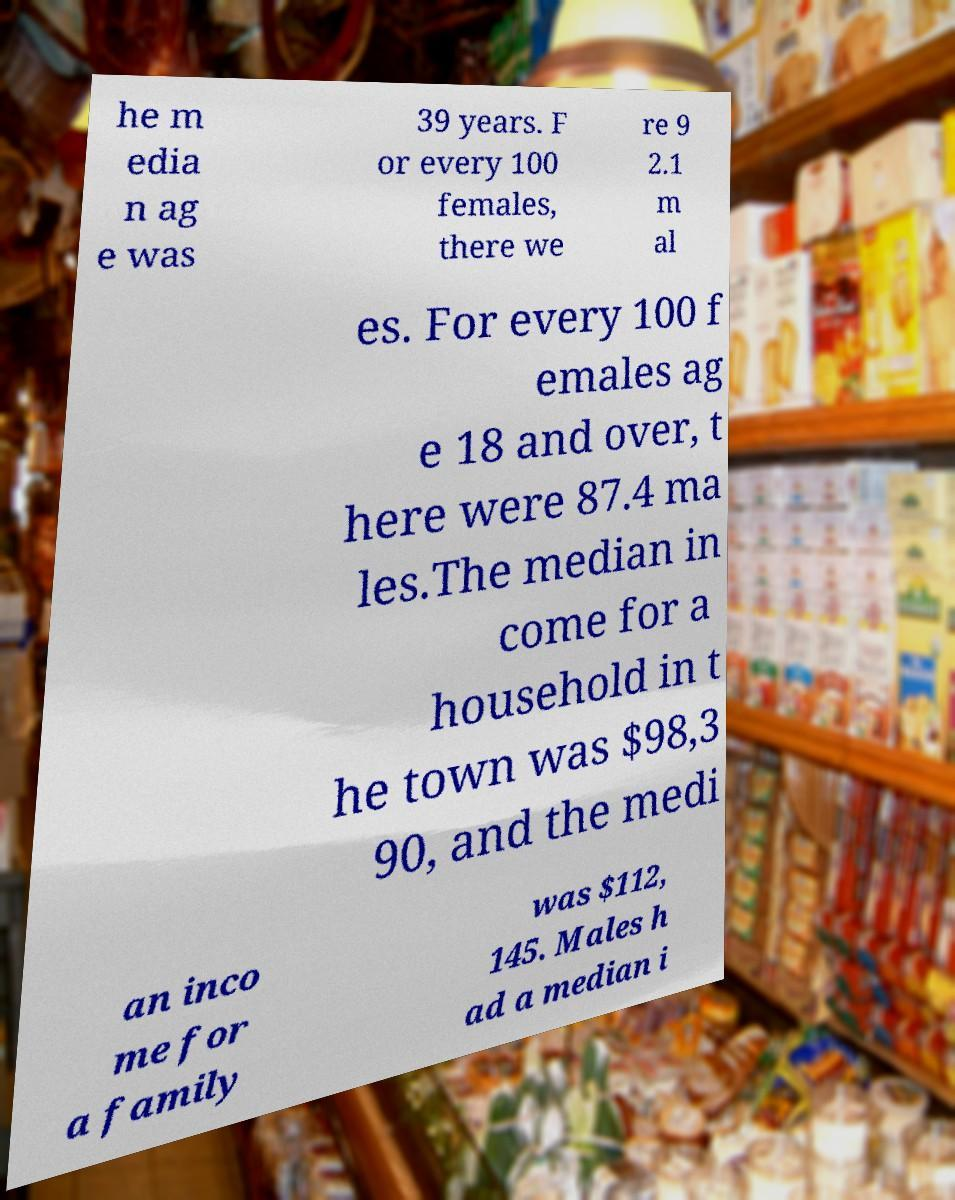Can you read and provide the text displayed in the image?This photo seems to have some interesting text. Can you extract and type it out for me? he m edia n ag e was 39 years. F or every 100 females, there we re 9 2.1 m al es. For every 100 f emales ag e 18 and over, t here were 87.4 ma les.The median in come for a household in t he town was $98,3 90, and the medi an inco me for a family was $112, 145. Males h ad a median i 